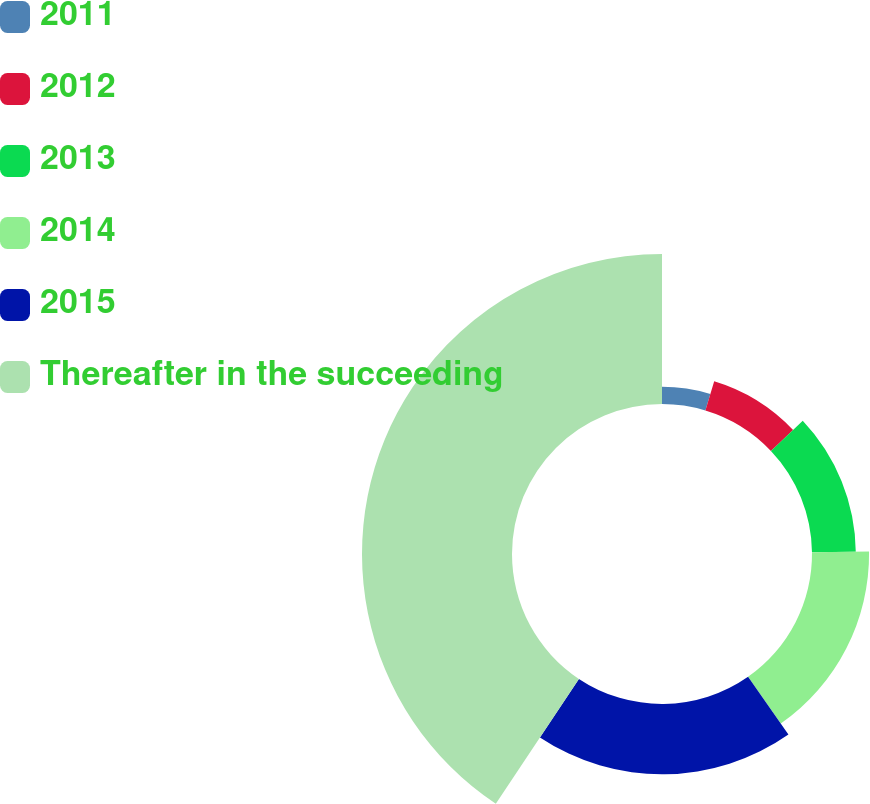Convert chart. <chart><loc_0><loc_0><loc_500><loc_500><pie_chart><fcel>2011<fcel>2012<fcel>2013<fcel>2014<fcel>2015<fcel>Thereafter in the succeeding<nl><fcel>4.67%<fcel>8.27%<fcel>11.87%<fcel>15.47%<fcel>19.07%<fcel>40.66%<nl></chart> 